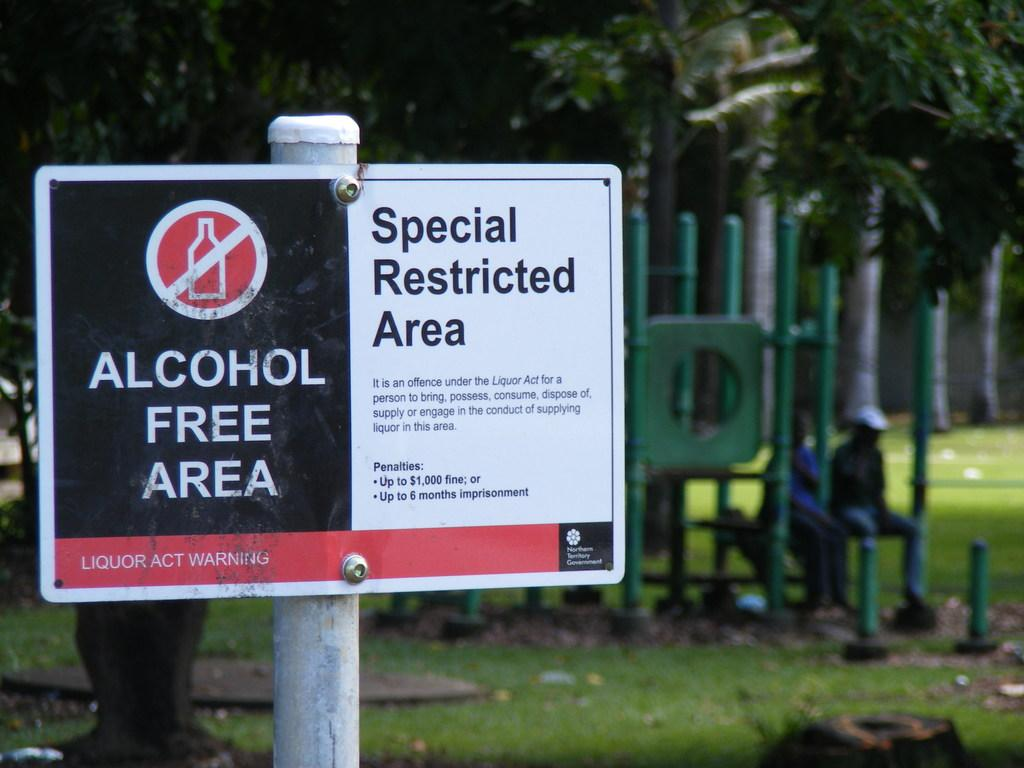What is attached to the pole in the image? There is a precaution board attached to the pole in the image. How many people are sitting in the image? There are two people sitting in the image. What type of vegetation can be seen in the backdrop of the image? There are trees and grass in the backdrop of the image. How is the backdrop of the image depicted? The backdrop is blurred in the image. What type of fruit is being marked by the people in the image? There is no fruit present in the image, and the people are not marking anything. 